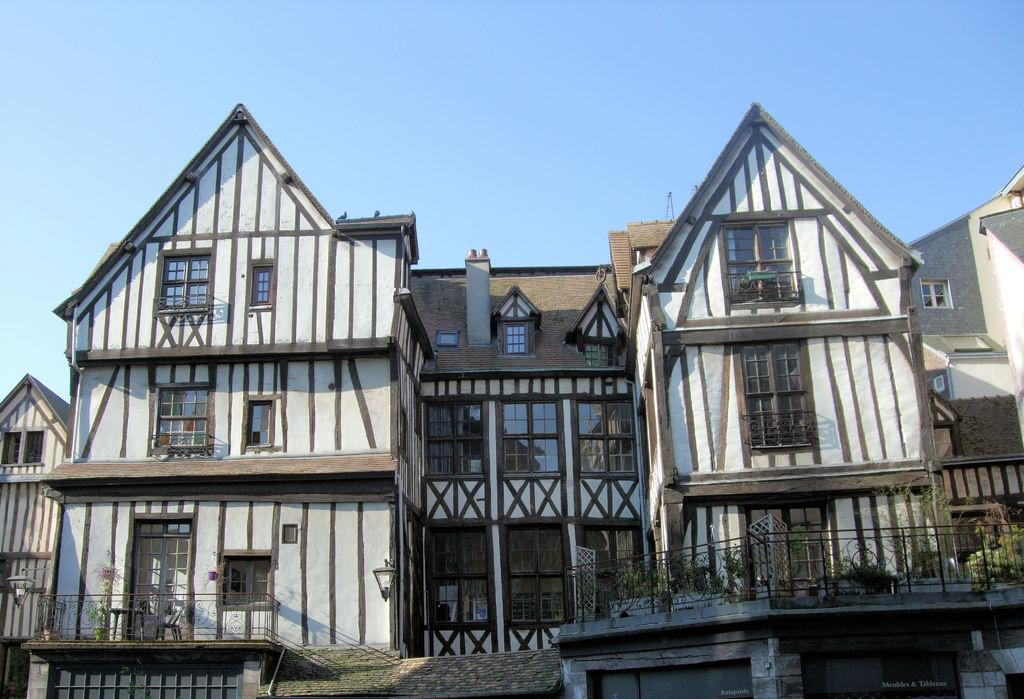What type of vegetation is on the right side of the image? There are plants on the right side of the image. What structures are located in the middle of the image? There are buildings in the middle of the image. What is visible at the top of the image? The sky is visible at the top of the image. How many sisters are sitting at the table in the image? There is no table or sisters present in the image. What advice does the uncle give to the plants in the image? There is no uncle present in the image, and therefore no advice can be given to the plants. 